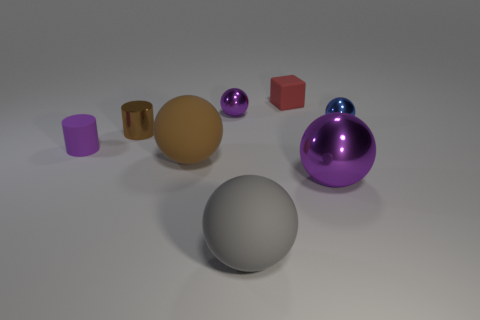Is there a big sphere of the same color as the small metal cylinder?
Offer a very short reply. Yes. What shape is the tiny metal thing that is the same color as the big metallic object?
Provide a short and direct response. Sphere. There is a big gray thing that is the same material as the red block; what shape is it?
Provide a succinct answer. Sphere. There is a rubber thing on the right side of the big matte ball on the right side of the purple shiny ball to the left of the red cube; what is its shape?
Provide a short and direct response. Cube. Are there more large gray rubber things than large yellow matte cylinders?
Keep it short and to the point. Yes. What material is the large gray thing that is the same shape as the small blue object?
Offer a very short reply. Rubber. Does the tiny blue ball have the same material as the gray thing?
Your answer should be compact. No. Are there more large gray objects in front of the red block than tiny yellow metal cylinders?
Give a very brief answer. Yes. The small cylinder that is in front of the brown thing left of the big thing that is behind the big metal object is made of what material?
Offer a very short reply. Rubber. What number of things are large green spheres or tiny purple objects in front of the blue metallic thing?
Provide a succinct answer. 1. 